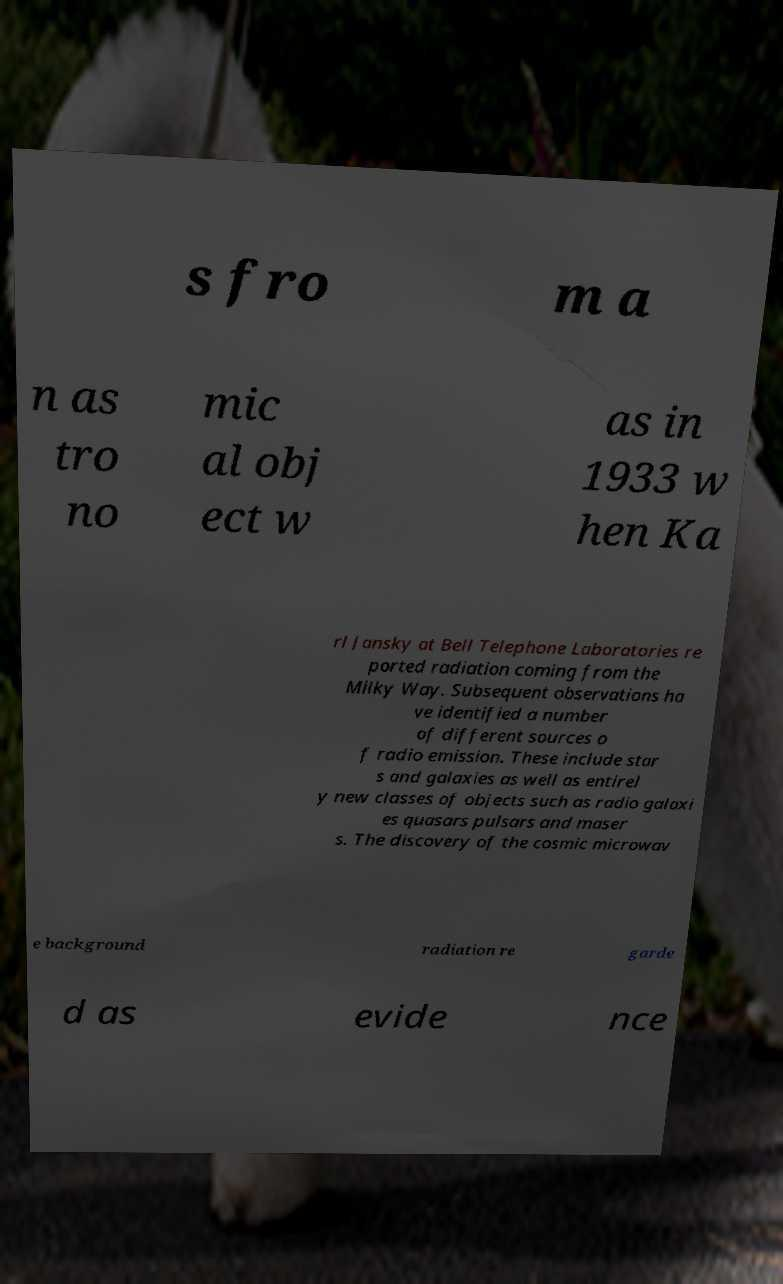Can you read and provide the text displayed in the image?This photo seems to have some interesting text. Can you extract and type it out for me? s fro m a n as tro no mic al obj ect w as in 1933 w hen Ka rl Jansky at Bell Telephone Laboratories re ported radiation coming from the Milky Way. Subsequent observations ha ve identified a number of different sources o f radio emission. These include star s and galaxies as well as entirel y new classes of objects such as radio galaxi es quasars pulsars and maser s. The discovery of the cosmic microwav e background radiation re garde d as evide nce 